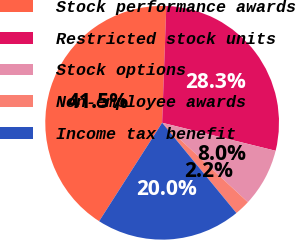<chart> <loc_0><loc_0><loc_500><loc_500><pie_chart><fcel>Stock performance awards<fcel>Restricted stock units<fcel>Stock options<fcel>Non-employee awards<fcel>Income tax benefit<nl><fcel>41.5%<fcel>28.28%<fcel>8.04%<fcel>2.15%<fcel>20.02%<nl></chart> 